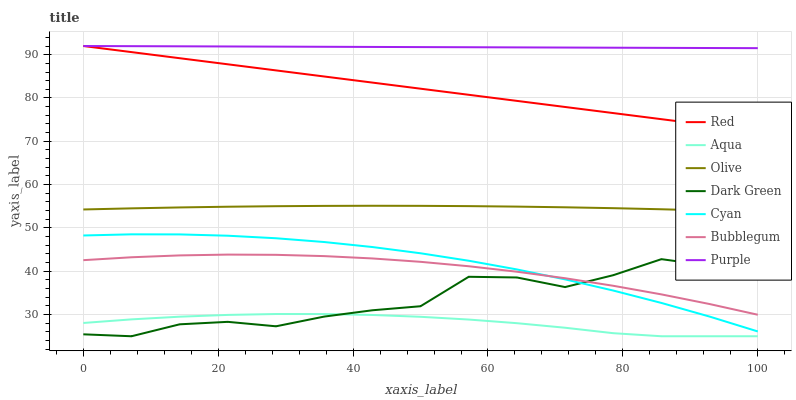Does Aqua have the minimum area under the curve?
Answer yes or no. Yes. Does Purple have the maximum area under the curve?
Answer yes or no. Yes. Does Bubblegum have the minimum area under the curve?
Answer yes or no. No. Does Bubblegum have the maximum area under the curve?
Answer yes or no. No. Is Purple the smoothest?
Answer yes or no. Yes. Is Dark Green the roughest?
Answer yes or no. Yes. Is Aqua the smoothest?
Answer yes or no. No. Is Aqua the roughest?
Answer yes or no. No. Does Aqua have the lowest value?
Answer yes or no. Yes. Does Bubblegum have the lowest value?
Answer yes or no. No. Does Red have the highest value?
Answer yes or no. Yes. Does Bubblegum have the highest value?
Answer yes or no. No. Is Cyan less than Olive?
Answer yes or no. Yes. Is Olive greater than Bubblegum?
Answer yes or no. Yes. Does Dark Green intersect Bubblegum?
Answer yes or no. Yes. Is Dark Green less than Bubblegum?
Answer yes or no. No. Is Dark Green greater than Bubblegum?
Answer yes or no. No. Does Cyan intersect Olive?
Answer yes or no. No. 